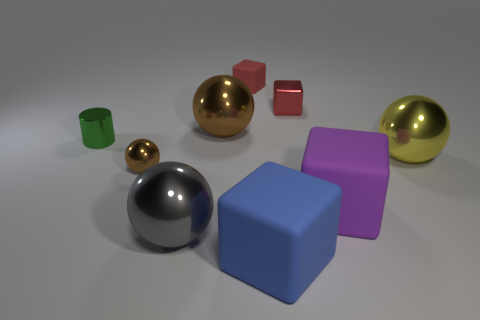What color is the other large object that is the same material as the large purple thing?
Give a very brief answer. Blue. There is a large rubber block in front of the gray shiny ball; what is its color?
Your answer should be very brief. Blue. What number of other rubber objects have the same color as the tiny matte object?
Your response must be concise. 0. Are there fewer small brown metallic balls that are behind the small brown shiny ball than spheres in front of the red metal thing?
Your answer should be very brief. Yes. What number of purple rubber objects are left of the tiny green object?
Give a very brief answer. 0. Is there a blue thing that has the same material as the purple block?
Your answer should be very brief. Yes. Are there more rubber blocks in front of the green object than big matte things that are right of the yellow metal object?
Provide a succinct answer. Yes. How big is the shiny cylinder?
Provide a short and direct response. Small. There is a metallic object that is to the right of the large purple matte cube; what is its shape?
Ensure brevity in your answer.  Sphere. Do the small red metal thing and the blue rubber thing have the same shape?
Your answer should be very brief. Yes. 